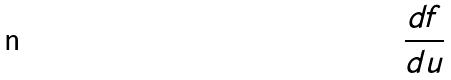Convert formula to latex. <formula><loc_0><loc_0><loc_500><loc_500>\frac { d f } { d u }</formula> 